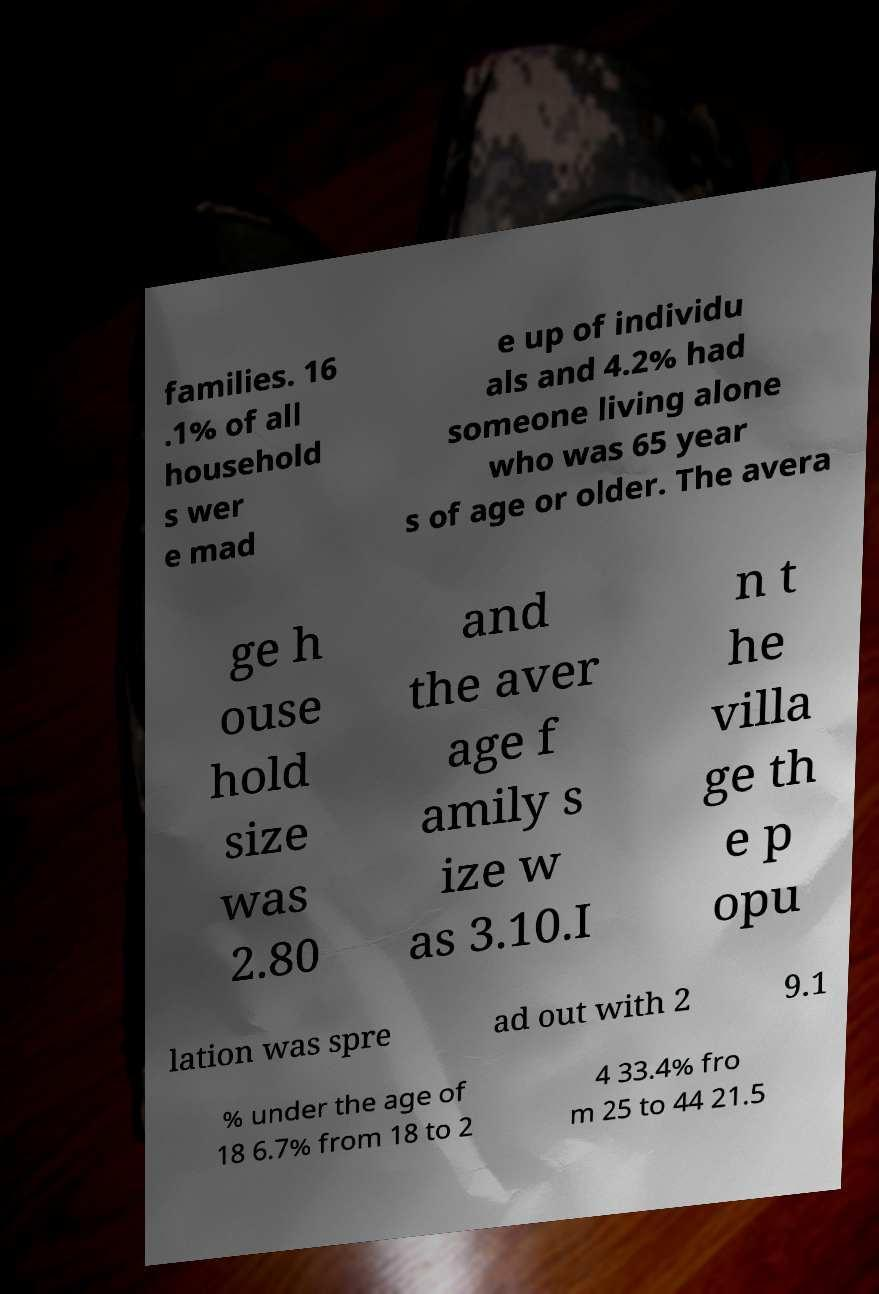Can you read and provide the text displayed in the image?This photo seems to have some interesting text. Can you extract and type it out for me? families. 16 .1% of all household s wer e mad e up of individu als and 4.2% had someone living alone who was 65 year s of age or older. The avera ge h ouse hold size was 2.80 and the aver age f amily s ize w as 3.10.I n t he villa ge th e p opu lation was spre ad out with 2 9.1 % under the age of 18 6.7% from 18 to 2 4 33.4% fro m 25 to 44 21.5 